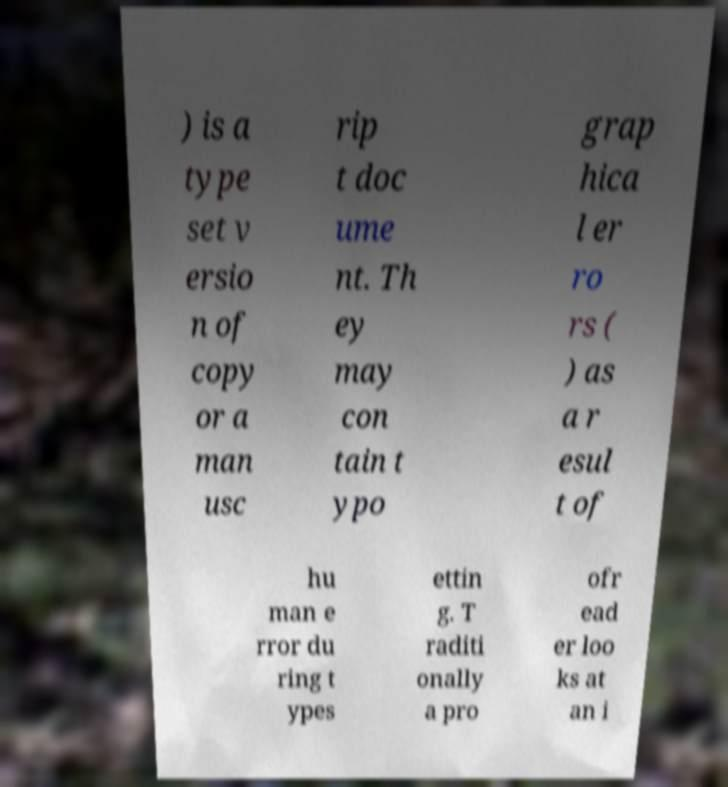What messages or text are displayed in this image? I need them in a readable, typed format. ) is a type set v ersio n of copy or a man usc rip t doc ume nt. Th ey may con tain t ypo grap hica l er ro rs ( ) as a r esul t of hu man e rror du ring t ypes ettin g. T raditi onally a pro ofr ead er loo ks at an i 